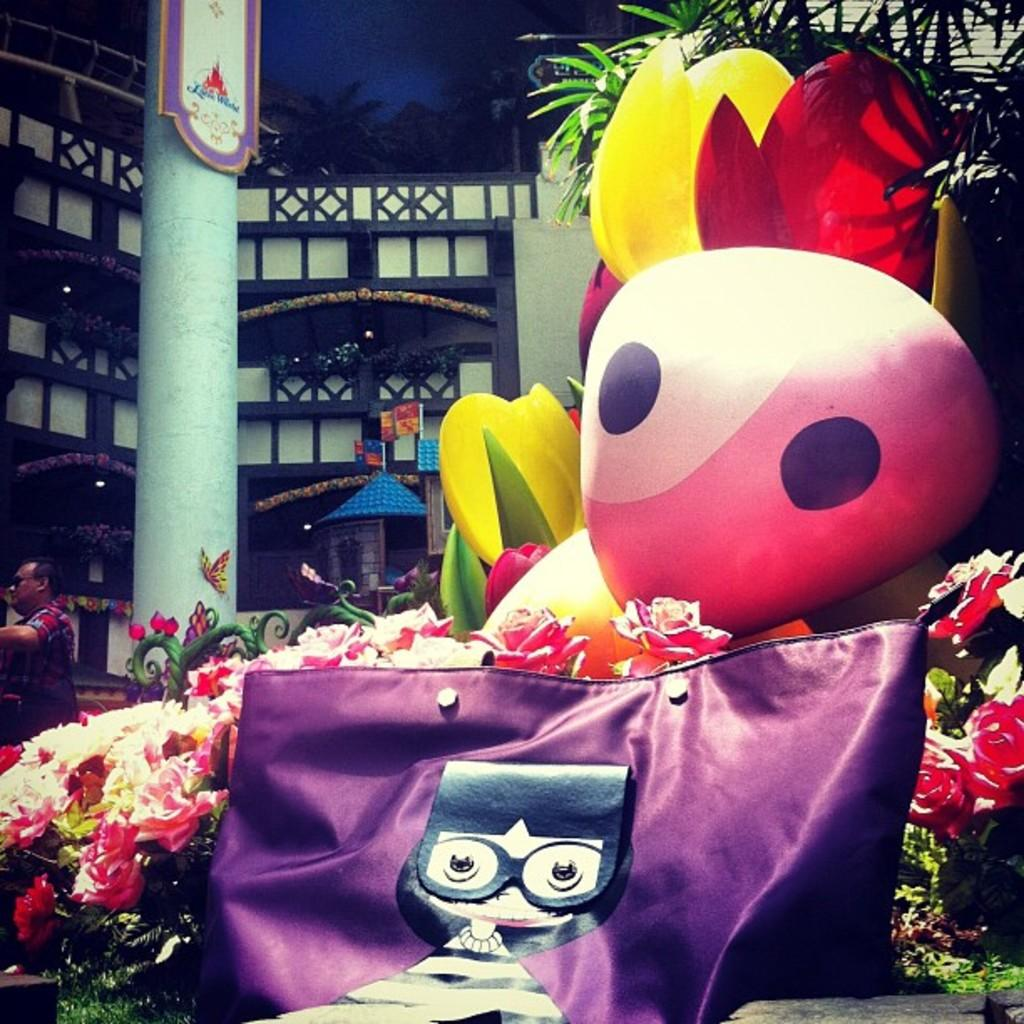What type of plants can be seen in the image? There are flowers in the image. What object is present in the image that might be used for carrying items? There is a bag in the image. What is floating in the image? There is a balloon in the image. Who is present in the image? There is a person standing in the image. What surface is the person standing on? The person is standing on the floor. What can be seen in the background of the image? There is a building in the background of the image. How many geese are flying over the building in the background of the image? There are no geese present in the image. What type of headwear is the person wearing in the image? The person is not wearing any headwear in the image. 